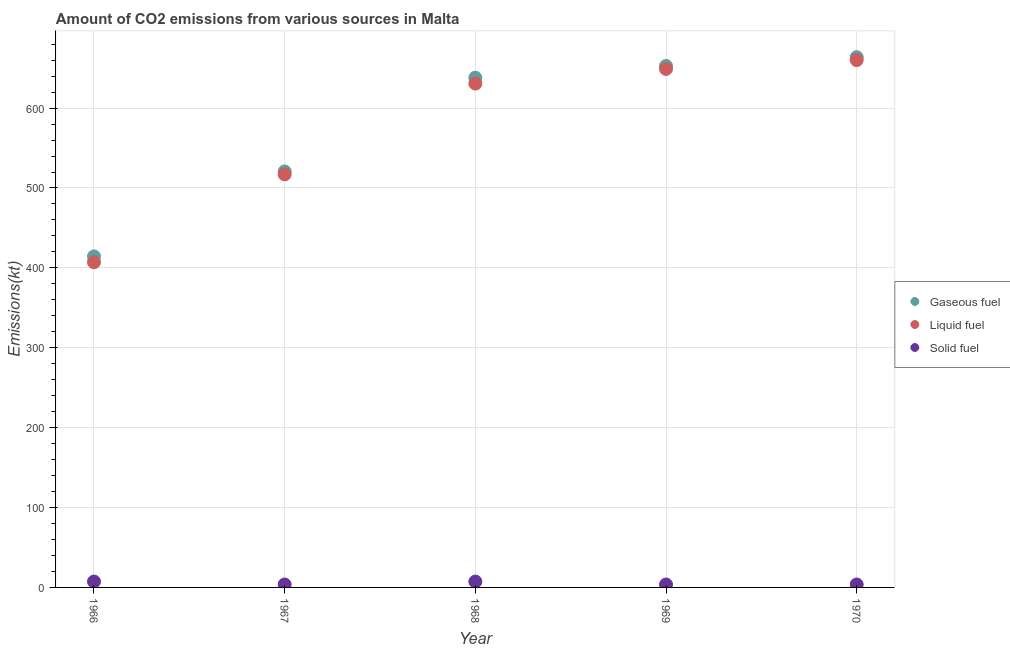What is the amount of co2 emissions from liquid fuel in 1970?
Your answer should be very brief. 660.06. Across all years, what is the maximum amount of co2 emissions from solid fuel?
Provide a succinct answer. 7.33. Across all years, what is the minimum amount of co2 emissions from solid fuel?
Give a very brief answer. 3.67. In which year was the amount of co2 emissions from liquid fuel maximum?
Keep it short and to the point. 1970. In which year was the amount of co2 emissions from solid fuel minimum?
Keep it short and to the point. 1967. What is the total amount of co2 emissions from gaseous fuel in the graph?
Keep it short and to the point. 2889.6. What is the difference between the amount of co2 emissions from liquid fuel in 1966 and that in 1970?
Provide a succinct answer. -253.02. What is the difference between the amount of co2 emissions from liquid fuel in 1969 and the amount of co2 emissions from solid fuel in 1970?
Your response must be concise. 645.39. What is the average amount of co2 emissions from liquid fuel per year?
Keep it short and to the point. 572.79. In the year 1966, what is the difference between the amount of co2 emissions from solid fuel and amount of co2 emissions from gaseous fuel?
Provide a short and direct response. -407.04. In how many years, is the amount of co2 emissions from gaseous fuel greater than 660 kt?
Offer a terse response. 1. What is the ratio of the amount of co2 emissions from gaseous fuel in 1966 to that in 1968?
Provide a short and direct response. 0.65. Is the amount of co2 emissions from solid fuel in 1966 less than that in 1968?
Give a very brief answer. No. What is the difference between the highest and the second highest amount of co2 emissions from gaseous fuel?
Your answer should be very brief. 11. What is the difference between the highest and the lowest amount of co2 emissions from liquid fuel?
Offer a very short reply. 253.02. In how many years, is the amount of co2 emissions from gaseous fuel greater than the average amount of co2 emissions from gaseous fuel taken over all years?
Ensure brevity in your answer.  3. Is the sum of the amount of co2 emissions from solid fuel in 1966 and 1967 greater than the maximum amount of co2 emissions from gaseous fuel across all years?
Ensure brevity in your answer.  No. Is it the case that in every year, the sum of the amount of co2 emissions from gaseous fuel and amount of co2 emissions from liquid fuel is greater than the amount of co2 emissions from solid fuel?
Offer a terse response. Yes. Does the amount of co2 emissions from solid fuel monotonically increase over the years?
Your response must be concise. No. Is the amount of co2 emissions from gaseous fuel strictly less than the amount of co2 emissions from liquid fuel over the years?
Provide a short and direct response. No. How many years are there in the graph?
Provide a short and direct response. 5. Does the graph contain grids?
Keep it short and to the point. Yes. Where does the legend appear in the graph?
Give a very brief answer. Center right. How are the legend labels stacked?
Provide a short and direct response. Vertical. What is the title of the graph?
Make the answer very short. Amount of CO2 emissions from various sources in Malta. What is the label or title of the X-axis?
Give a very brief answer. Year. What is the label or title of the Y-axis?
Offer a very short reply. Emissions(kt). What is the Emissions(kt) in Gaseous fuel in 1966?
Provide a short and direct response. 414.37. What is the Emissions(kt) in Liquid fuel in 1966?
Offer a very short reply. 407.04. What is the Emissions(kt) of Solid fuel in 1966?
Provide a short and direct response. 7.33. What is the Emissions(kt) in Gaseous fuel in 1967?
Offer a terse response. 520.71. What is the Emissions(kt) in Liquid fuel in 1967?
Ensure brevity in your answer.  517.05. What is the Emissions(kt) in Solid fuel in 1967?
Your answer should be compact. 3.67. What is the Emissions(kt) of Gaseous fuel in 1968?
Give a very brief answer. 638.06. What is the Emissions(kt) in Liquid fuel in 1968?
Give a very brief answer. 630.72. What is the Emissions(kt) in Solid fuel in 1968?
Offer a terse response. 7.33. What is the Emissions(kt) in Gaseous fuel in 1969?
Keep it short and to the point. 652.73. What is the Emissions(kt) of Liquid fuel in 1969?
Your answer should be compact. 649.06. What is the Emissions(kt) of Solid fuel in 1969?
Your response must be concise. 3.67. What is the Emissions(kt) of Gaseous fuel in 1970?
Provide a short and direct response. 663.73. What is the Emissions(kt) in Liquid fuel in 1970?
Keep it short and to the point. 660.06. What is the Emissions(kt) of Solid fuel in 1970?
Offer a very short reply. 3.67. Across all years, what is the maximum Emissions(kt) of Gaseous fuel?
Keep it short and to the point. 663.73. Across all years, what is the maximum Emissions(kt) in Liquid fuel?
Give a very brief answer. 660.06. Across all years, what is the maximum Emissions(kt) of Solid fuel?
Provide a short and direct response. 7.33. Across all years, what is the minimum Emissions(kt) in Gaseous fuel?
Ensure brevity in your answer.  414.37. Across all years, what is the minimum Emissions(kt) of Liquid fuel?
Offer a terse response. 407.04. Across all years, what is the minimum Emissions(kt) of Solid fuel?
Make the answer very short. 3.67. What is the total Emissions(kt) of Gaseous fuel in the graph?
Your answer should be compact. 2889.6. What is the total Emissions(kt) of Liquid fuel in the graph?
Provide a succinct answer. 2863.93. What is the total Emissions(kt) of Solid fuel in the graph?
Provide a succinct answer. 25.67. What is the difference between the Emissions(kt) in Gaseous fuel in 1966 and that in 1967?
Ensure brevity in your answer.  -106.34. What is the difference between the Emissions(kt) in Liquid fuel in 1966 and that in 1967?
Offer a terse response. -110.01. What is the difference between the Emissions(kt) in Solid fuel in 1966 and that in 1967?
Offer a terse response. 3.67. What is the difference between the Emissions(kt) of Gaseous fuel in 1966 and that in 1968?
Make the answer very short. -223.69. What is the difference between the Emissions(kt) in Liquid fuel in 1966 and that in 1968?
Provide a short and direct response. -223.69. What is the difference between the Emissions(kt) of Solid fuel in 1966 and that in 1968?
Provide a succinct answer. 0. What is the difference between the Emissions(kt) in Gaseous fuel in 1966 and that in 1969?
Your response must be concise. -238.35. What is the difference between the Emissions(kt) in Liquid fuel in 1966 and that in 1969?
Keep it short and to the point. -242.02. What is the difference between the Emissions(kt) of Solid fuel in 1966 and that in 1969?
Offer a terse response. 3.67. What is the difference between the Emissions(kt) in Gaseous fuel in 1966 and that in 1970?
Offer a terse response. -249.36. What is the difference between the Emissions(kt) of Liquid fuel in 1966 and that in 1970?
Your answer should be very brief. -253.02. What is the difference between the Emissions(kt) of Solid fuel in 1966 and that in 1970?
Give a very brief answer. 3.67. What is the difference between the Emissions(kt) of Gaseous fuel in 1967 and that in 1968?
Provide a short and direct response. -117.34. What is the difference between the Emissions(kt) of Liquid fuel in 1967 and that in 1968?
Offer a terse response. -113.68. What is the difference between the Emissions(kt) of Solid fuel in 1967 and that in 1968?
Your response must be concise. -3.67. What is the difference between the Emissions(kt) in Gaseous fuel in 1967 and that in 1969?
Your answer should be very brief. -132.01. What is the difference between the Emissions(kt) of Liquid fuel in 1967 and that in 1969?
Provide a short and direct response. -132.01. What is the difference between the Emissions(kt) in Gaseous fuel in 1967 and that in 1970?
Offer a very short reply. -143.01. What is the difference between the Emissions(kt) of Liquid fuel in 1967 and that in 1970?
Provide a short and direct response. -143.01. What is the difference between the Emissions(kt) in Gaseous fuel in 1968 and that in 1969?
Your response must be concise. -14.67. What is the difference between the Emissions(kt) of Liquid fuel in 1968 and that in 1969?
Keep it short and to the point. -18.34. What is the difference between the Emissions(kt) in Solid fuel in 1968 and that in 1969?
Keep it short and to the point. 3.67. What is the difference between the Emissions(kt) in Gaseous fuel in 1968 and that in 1970?
Your answer should be very brief. -25.67. What is the difference between the Emissions(kt) of Liquid fuel in 1968 and that in 1970?
Provide a short and direct response. -29.34. What is the difference between the Emissions(kt) of Solid fuel in 1968 and that in 1970?
Offer a very short reply. 3.67. What is the difference between the Emissions(kt) of Gaseous fuel in 1969 and that in 1970?
Your answer should be very brief. -11. What is the difference between the Emissions(kt) of Liquid fuel in 1969 and that in 1970?
Give a very brief answer. -11. What is the difference between the Emissions(kt) in Gaseous fuel in 1966 and the Emissions(kt) in Liquid fuel in 1967?
Your response must be concise. -102.68. What is the difference between the Emissions(kt) of Gaseous fuel in 1966 and the Emissions(kt) of Solid fuel in 1967?
Your answer should be compact. 410.7. What is the difference between the Emissions(kt) in Liquid fuel in 1966 and the Emissions(kt) in Solid fuel in 1967?
Offer a terse response. 403.37. What is the difference between the Emissions(kt) of Gaseous fuel in 1966 and the Emissions(kt) of Liquid fuel in 1968?
Provide a short and direct response. -216.35. What is the difference between the Emissions(kt) of Gaseous fuel in 1966 and the Emissions(kt) of Solid fuel in 1968?
Your answer should be very brief. 407.04. What is the difference between the Emissions(kt) in Liquid fuel in 1966 and the Emissions(kt) in Solid fuel in 1968?
Offer a terse response. 399.7. What is the difference between the Emissions(kt) in Gaseous fuel in 1966 and the Emissions(kt) in Liquid fuel in 1969?
Ensure brevity in your answer.  -234.69. What is the difference between the Emissions(kt) in Gaseous fuel in 1966 and the Emissions(kt) in Solid fuel in 1969?
Your response must be concise. 410.7. What is the difference between the Emissions(kt) in Liquid fuel in 1966 and the Emissions(kt) in Solid fuel in 1969?
Your answer should be compact. 403.37. What is the difference between the Emissions(kt) in Gaseous fuel in 1966 and the Emissions(kt) in Liquid fuel in 1970?
Your answer should be compact. -245.69. What is the difference between the Emissions(kt) in Gaseous fuel in 1966 and the Emissions(kt) in Solid fuel in 1970?
Your answer should be compact. 410.7. What is the difference between the Emissions(kt) in Liquid fuel in 1966 and the Emissions(kt) in Solid fuel in 1970?
Provide a short and direct response. 403.37. What is the difference between the Emissions(kt) in Gaseous fuel in 1967 and the Emissions(kt) in Liquid fuel in 1968?
Ensure brevity in your answer.  -110.01. What is the difference between the Emissions(kt) of Gaseous fuel in 1967 and the Emissions(kt) of Solid fuel in 1968?
Offer a very short reply. 513.38. What is the difference between the Emissions(kt) in Liquid fuel in 1967 and the Emissions(kt) in Solid fuel in 1968?
Make the answer very short. 509.71. What is the difference between the Emissions(kt) in Gaseous fuel in 1967 and the Emissions(kt) in Liquid fuel in 1969?
Give a very brief answer. -128.34. What is the difference between the Emissions(kt) of Gaseous fuel in 1967 and the Emissions(kt) of Solid fuel in 1969?
Offer a very short reply. 517.05. What is the difference between the Emissions(kt) of Liquid fuel in 1967 and the Emissions(kt) of Solid fuel in 1969?
Provide a short and direct response. 513.38. What is the difference between the Emissions(kt) of Gaseous fuel in 1967 and the Emissions(kt) of Liquid fuel in 1970?
Give a very brief answer. -139.35. What is the difference between the Emissions(kt) of Gaseous fuel in 1967 and the Emissions(kt) of Solid fuel in 1970?
Your answer should be compact. 517.05. What is the difference between the Emissions(kt) in Liquid fuel in 1967 and the Emissions(kt) in Solid fuel in 1970?
Give a very brief answer. 513.38. What is the difference between the Emissions(kt) of Gaseous fuel in 1968 and the Emissions(kt) of Liquid fuel in 1969?
Provide a succinct answer. -11. What is the difference between the Emissions(kt) in Gaseous fuel in 1968 and the Emissions(kt) in Solid fuel in 1969?
Ensure brevity in your answer.  634.39. What is the difference between the Emissions(kt) in Liquid fuel in 1968 and the Emissions(kt) in Solid fuel in 1969?
Offer a very short reply. 627.06. What is the difference between the Emissions(kt) in Gaseous fuel in 1968 and the Emissions(kt) in Liquid fuel in 1970?
Keep it short and to the point. -22. What is the difference between the Emissions(kt) of Gaseous fuel in 1968 and the Emissions(kt) of Solid fuel in 1970?
Your answer should be very brief. 634.39. What is the difference between the Emissions(kt) in Liquid fuel in 1968 and the Emissions(kt) in Solid fuel in 1970?
Ensure brevity in your answer.  627.06. What is the difference between the Emissions(kt) in Gaseous fuel in 1969 and the Emissions(kt) in Liquid fuel in 1970?
Your answer should be very brief. -7.33. What is the difference between the Emissions(kt) in Gaseous fuel in 1969 and the Emissions(kt) in Solid fuel in 1970?
Ensure brevity in your answer.  649.06. What is the difference between the Emissions(kt) of Liquid fuel in 1969 and the Emissions(kt) of Solid fuel in 1970?
Offer a very short reply. 645.39. What is the average Emissions(kt) of Gaseous fuel per year?
Provide a succinct answer. 577.92. What is the average Emissions(kt) in Liquid fuel per year?
Your answer should be compact. 572.79. What is the average Emissions(kt) in Solid fuel per year?
Make the answer very short. 5.13. In the year 1966, what is the difference between the Emissions(kt) of Gaseous fuel and Emissions(kt) of Liquid fuel?
Make the answer very short. 7.33. In the year 1966, what is the difference between the Emissions(kt) in Gaseous fuel and Emissions(kt) in Solid fuel?
Give a very brief answer. 407.04. In the year 1966, what is the difference between the Emissions(kt) in Liquid fuel and Emissions(kt) in Solid fuel?
Offer a very short reply. 399.7. In the year 1967, what is the difference between the Emissions(kt) of Gaseous fuel and Emissions(kt) of Liquid fuel?
Your response must be concise. 3.67. In the year 1967, what is the difference between the Emissions(kt) of Gaseous fuel and Emissions(kt) of Solid fuel?
Offer a terse response. 517.05. In the year 1967, what is the difference between the Emissions(kt) of Liquid fuel and Emissions(kt) of Solid fuel?
Offer a terse response. 513.38. In the year 1968, what is the difference between the Emissions(kt) in Gaseous fuel and Emissions(kt) in Liquid fuel?
Keep it short and to the point. 7.33. In the year 1968, what is the difference between the Emissions(kt) of Gaseous fuel and Emissions(kt) of Solid fuel?
Your answer should be very brief. 630.72. In the year 1968, what is the difference between the Emissions(kt) of Liquid fuel and Emissions(kt) of Solid fuel?
Keep it short and to the point. 623.39. In the year 1969, what is the difference between the Emissions(kt) of Gaseous fuel and Emissions(kt) of Liquid fuel?
Make the answer very short. 3.67. In the year 1969, what is the difference between the Emissions(kt) of Gaseous fuel and Emissions(kt) of Solid fuel?
Make the answer very short. 649.06. In the year 1969, what is the difference between the Emissions(kt) in Liquid fuel and Emissions(kt) in Solid fuel?
Provide a succinct answer. 645.39. In the year 1970, what is the difference between the Emissions(kt) of Gaseous fuel and Emissions(kt) of Liquid fuel?
Your response must be concise. 3.67. In the year 1970, what is the difference between the Emissions(kt) of Gaseous fuel and Emissions(kt) of Solid fuel?
Offer a terse response. 660.06. In the year 1970, what is the difference between the Emissions(kt) of Liquid fuel and Emissions(kt) of Solid fuel?
Keep it short and to the point. 656.39. What is the ratio of the Emissions(kt) in Gaseous fuel in 1966 to that in 1967?
Provide a succinct answer. 0.8. What is the ratio of the Emissions(kt) of Liquid fuel in 1966 to that in 1967?
Make the answer very short. 0.79. What is the ratio of the Emissions(kt) in Solid fuel in 1966 to that in 1967?
Give a very brief answer. 2. What is the ratio of the Emissions(kt) of Gaseous fuel in 1966 to that in 1968?
Your answer should be compact. 0.65. What is the ratio of the Emissions(kt) in Liquid fuel in 1966 to that in 1968?
Ensure brevity in your answer.  0.65. What is the ratio of the Emissions(kt) of Gaseous fuel in 1966 to that in 1969?
Provide a short and direct response. 0.63. What is the ratio of the Emissions(kt) of Liquid fuel in 1966 to that in 1969?
Provide a short and direct response. 0.63. What is the ratio of the Emissions(kt) of Solid fuel in 1966 to that in 1969?
Keep it short and to the point. 2. What is the ratio of the Emissions(kt) of Gaseous fuel in 1966 to that in 1970?
Provide a short and direct response. 0.62. What is the ratio of the Emissions(kt) in Liquid fuel in 1966 to that in 1970?
Make the answer very short. 0.62. What is the ratio of the Emissions(kt) in Gaseous fuel in 1967 to that in 1968?
Give a very brief answer. 0.82. What is the ratio of the Emissions(kt) of Liquid fuel in 1967 to that in 1968?
Your answer should be compact. 0.82. What is the ratio of the Emissions(kt) of Solid fuel in 1967 to that in 1968?
Your answer should be very brief. 0.5. What is the ratio of the Emissions(kt) in Gaseous fuel in 1967 to that in 1969?
Give a very brief answer. 0.8. What is the ratio of the Emissions(kt) in Liquid fuel in 1967 to that in 1969?
Make the answer very short. 0.8. What is the ratio of the Emissions(kt) in Gaseous fuel in 1967 to that in 1970?
Ensure brevity in your answer.  0.78. What is the ratio of the Emissions(kt) of Liquid fuel in 1967 to that in 1970?
Your answer should be compact. 0.78. What is the ratio of the Emissions(kt) of Solid fuel in 1967 to that in 1970?
Provide a succinct answer. 1. What is the ratio of the Emissions(kt) of Gaseous fuel in 1968 to that in 1969?
Offer a very short reply. 0.98. What is the ratio of the Emissions(kt) of Liquid fuel in 1968 to that in 1969?
Ensure brevity in your answer.  0.97. What is the ratio of the Emissions(kt) of Solid fuel in 1968 to that in 1969?
Provide a short and direct response. 2. What is the ratio of the Emissions(kt) of Gaseous fuel in 1968 to that in 1970?
Give a very brief answer. 0.96. What is the ratio of the Emissions(kt) in Liquid fuel in 1968 to that in 1970?
Provide a succinct answer. 0.96. What is the ratio of the Emissions(kt) of Solid fuel in 1968 to that in 1970?
Provide a succinct answer. 2. What is the ratio of the Emissions(kt) in Gaseous fuel in 1969 to that in 1970?
Give a very brief answer. 0.98. What is the ratio of the Emissions(kt) in Liquid fuel in 1969 to that in 1970?
Provide a short and direct response. 0.98. What is the difference between the highest and the second highest Emissions(kt) of Gaseous fuel?
Offer a very short reply. 11. What is the difference between the highest and the second highest Emissions(kt) of Liquid fuel?
Your answer should be very brief. 11. What is the difference between the highest and the lowest Emissions(kt) of Gaseous fuel?
Your answer should be compact. 249.36. What is the difference between the highest and the lowest Emissions(kt) of Liquid fuel?
Your response must be concise. 253.02. What is the difference between the highest and the lowest Emissions(kt) in Solid fuel?
Offer a terse response. 3.67. 